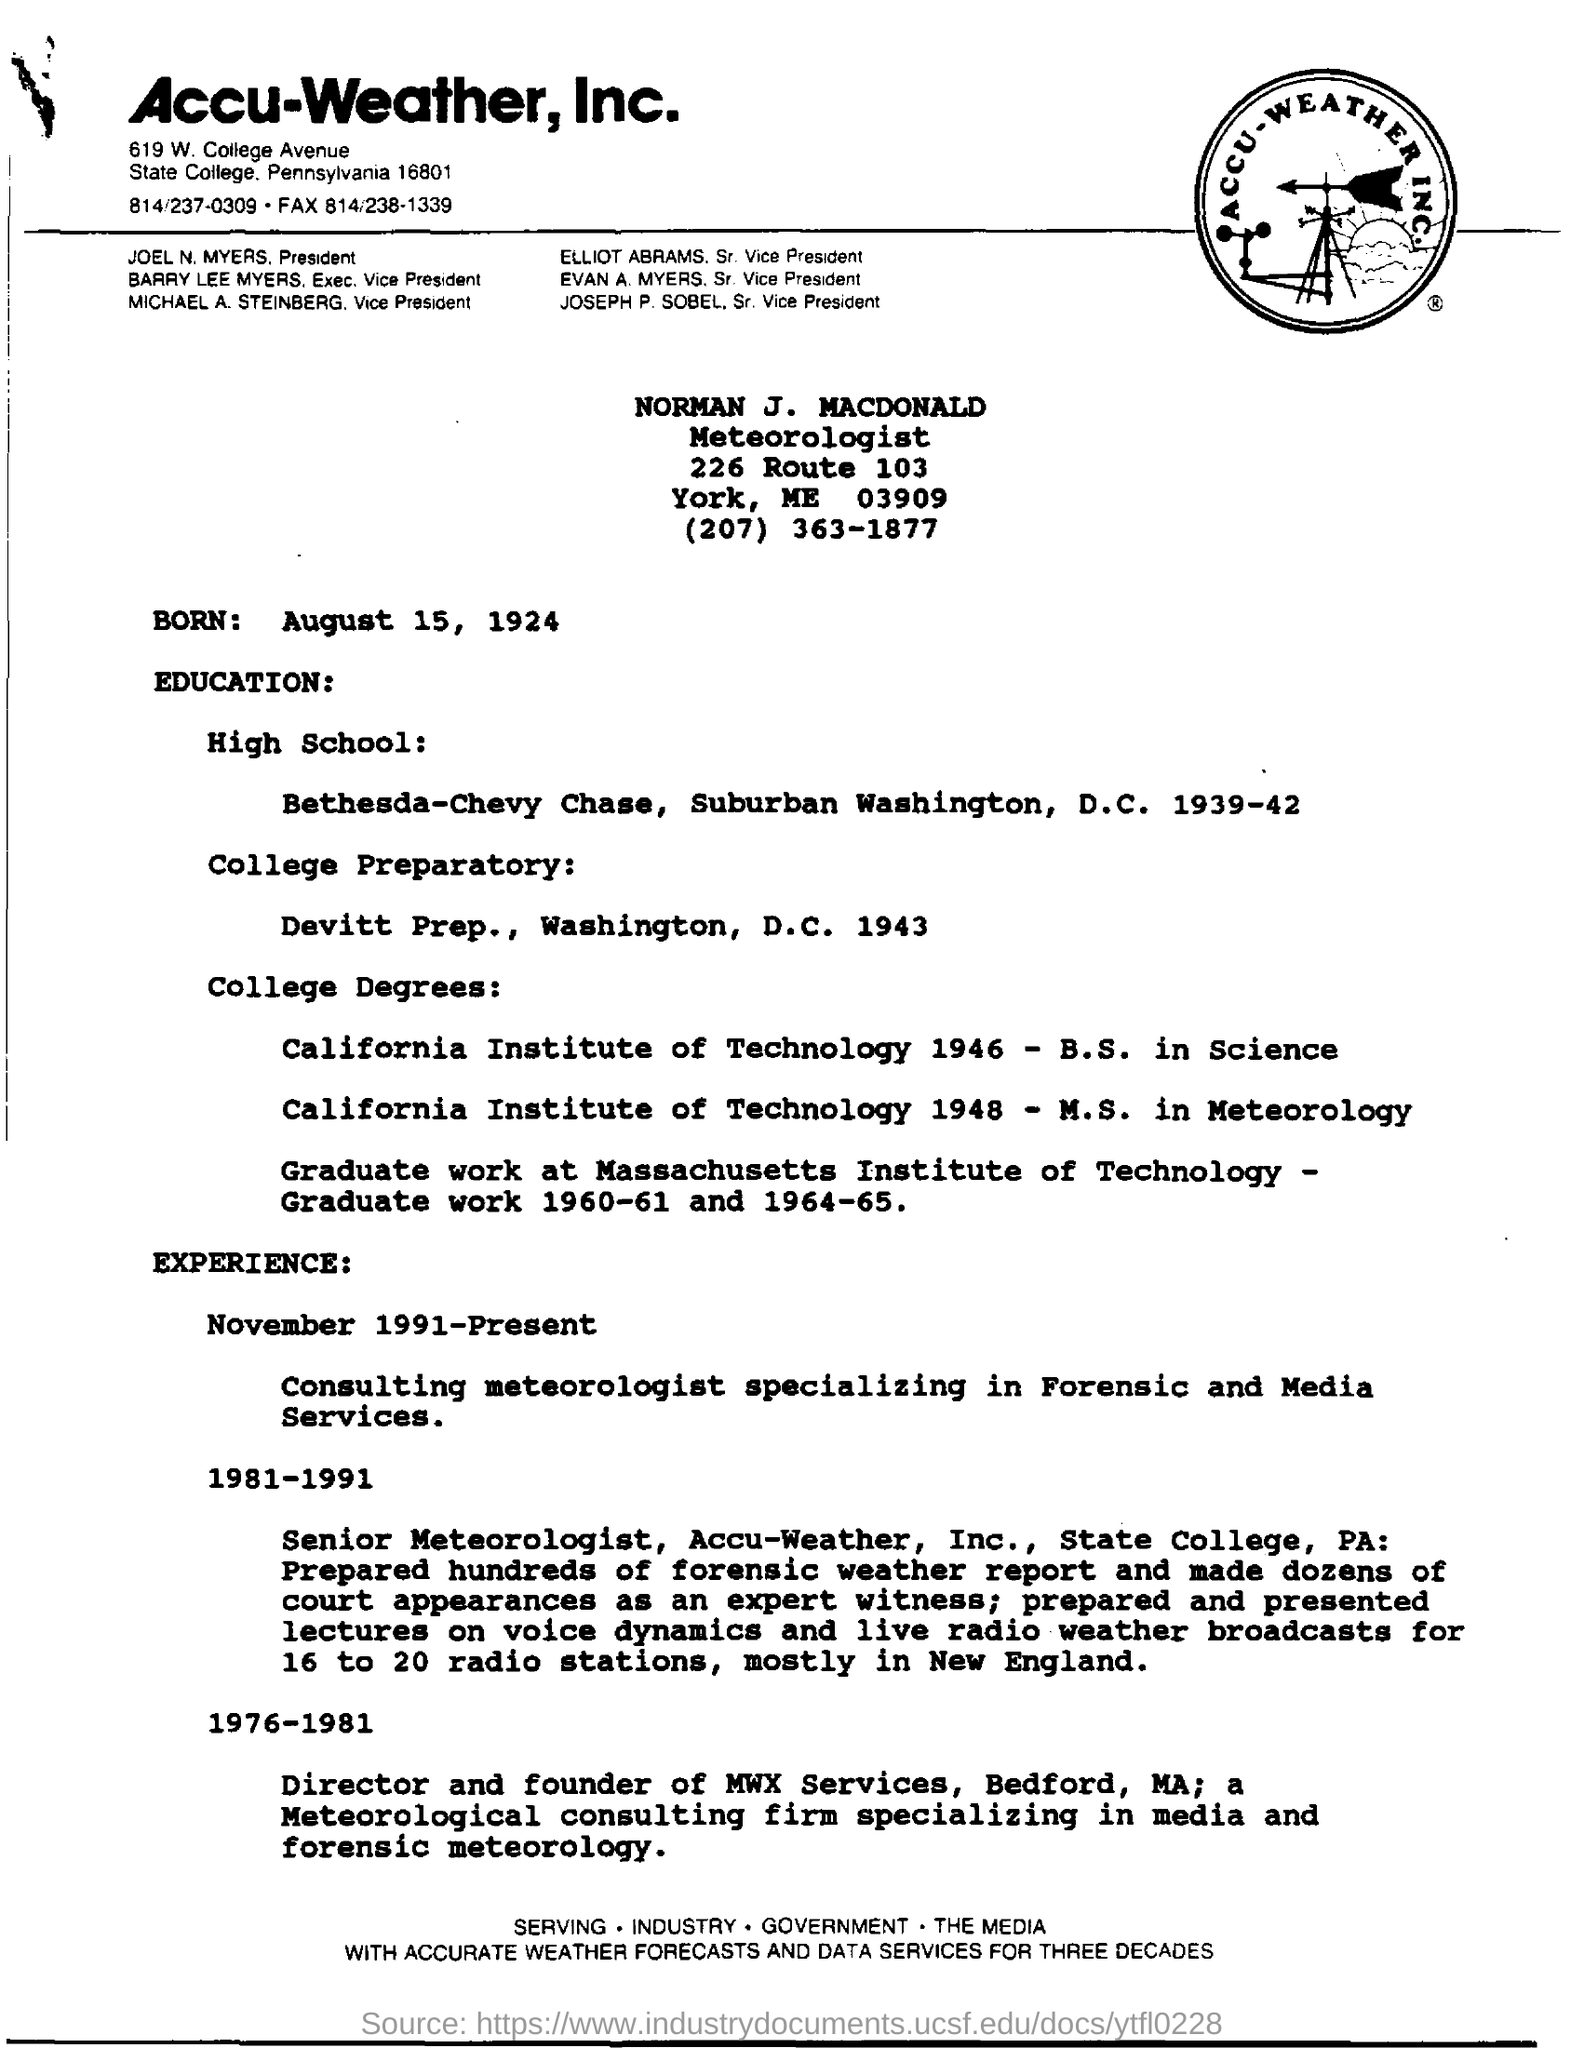List a handful of essential elements in this visual. Accu-Weather, Inc. is mentioned in the letterhead. Norman J. Macdonald's designation is that of a meteorologist. August 15, 1924 is the date of birth. Norman J. Macdonald was born on August 15, 1924. 